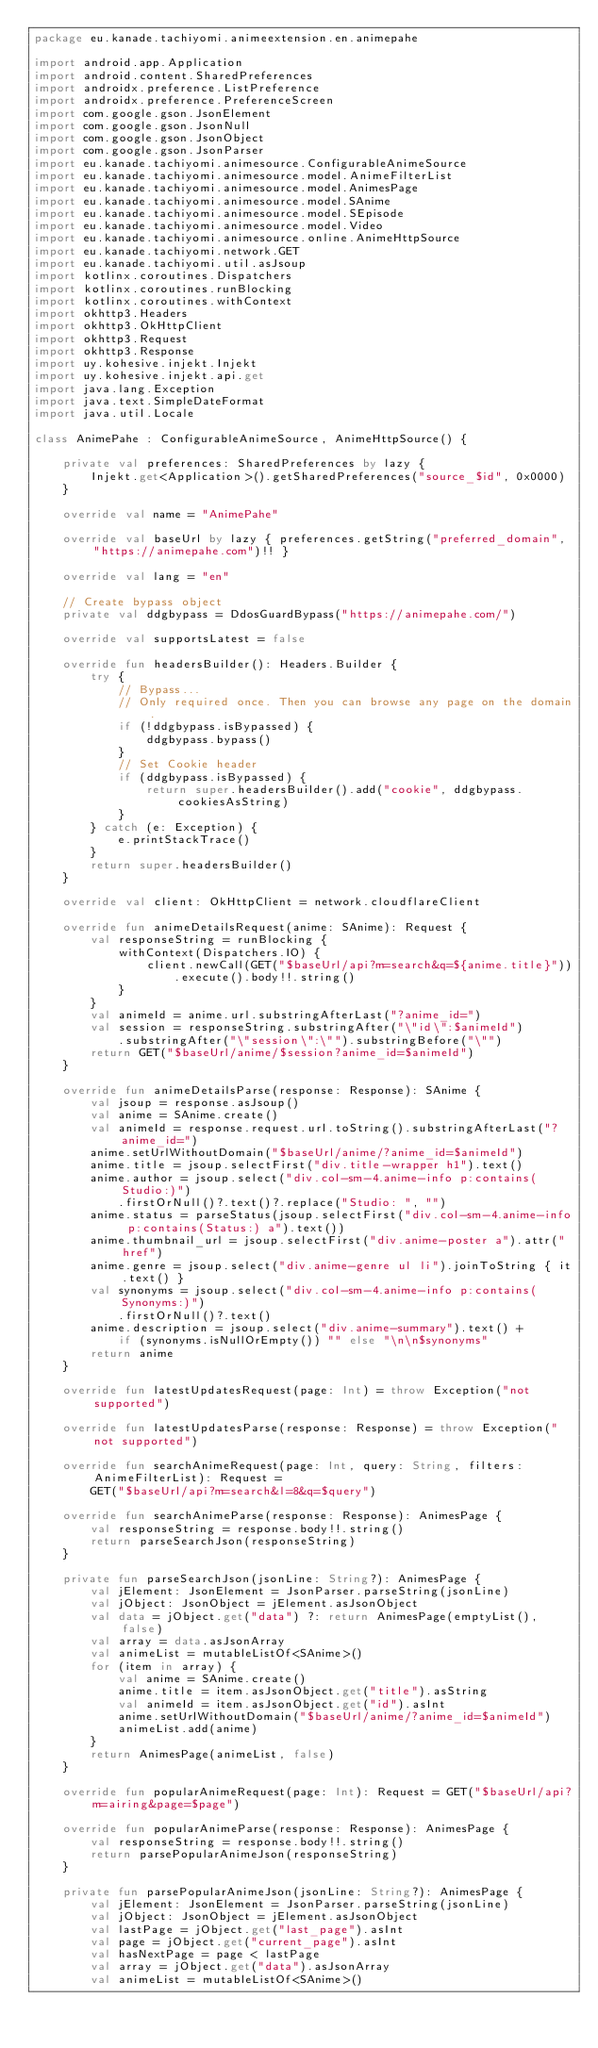Convert code to text. <code><loc_0><loc_0><loc_500><loc_500><_Kotlin_>package eu.kanade.tachiyomi.animeextension.en.animepahe

import android.app.Application
import android.content.SharedPreferences
import androidx.preference.ListPreference
import androidx.preference.PreferenceScreen
import com.google.gson.JsonElement
import com.google.gson.JsonNull
import com.google.gson.JsonObject
import com.google.gson.JsonParser
import eu.kanade.tachiyomi.animesource.ConfigurableAnimeSource
import eu.kanade.tachiyomi.animesource.model.AnimeFilterList
import eu.kanade.tachiyomi.animesource.model.AnimesPage
import eu.kanade.tachiyomi.animesource.model.SAnime
import eu.kanade.tachiyomi.animesource.model.SEpisode
import eu.kanade.tachiyomi.animesource.model.Video
import eu.kanade.tachiyomi.animesource.online.AnimeHttpSource
import eu.kanade.tachiyomi.network.GET
import eu.kanade.tachiyomi.util.asJsoup
import kotlinx.coroutines.Dispatchers
import kotlinx.coroutines.runBlocking
import kotlinx.coroutines.withContext
import okhttp3.Headers
import okhttp3.OkHttpClient
import okhttp3.Request
import okhttp3.Response
import uy.kohesive.injekt.Injekt
import uy.kohesive.injekt.api.get
import java.lang.Exception
import java.text.SimpleDateFormat
import java.util.Locale

class AnimePahe : ConfigurableAnimeSource, AnimeHttpSource() {

    private val preferences: SharedPreferences by lazy {
        Injekt.get<Application>().getSharedPreferences("source_$id", 0x0000)
    }

    override val name = "AnimePahe"

    override val baseUrl by lazy { preferences.getString("preferred_domain", "https://animepahe.com")!! }

    override val lang = "en"

    // Create bypass object
    private val ddgbypass = DdosGuardBypass("https://animepahe.com/")

    override val supportsLatest = false

    override fun headersBuilder(): Headers.Builder {
        try {
            // Bypass...
            // Only required once. Then you can browse any page on the domain.
            if (!ddgbypass.isBypassed) {
                ddgbypass.bypass()
            }
            // Set Cookie header
            if (ddgbypass.isBypassed) {
                return super.headersBuilder().add("cookie", ddgbypass.cookiesAsString)
            }
        } catch (e: Exception) {
            e.printStackTrace()
        }
        return super.headersBuilder()
    }

    override val client: OkHttpClient = network.cloudflareClient

    override fun animeDetailsRequest(anime: SAnime): Request {
        val responseString = runBlocking {
            withContext(Dispatchers.IO) {
                client.newCall(GET("$baseUrl/api?m=search&q=${anime.title}"))
                    .execute().body!!.string()
            }
        }
        val animeId = anime.url.substringAfterLast("?anime_id=")
        val session = responseString.substringAfter("\"id\":$animeId")
            .substringAfter("\"session\":\"").substringBefore("\"")
        return GET("$baseUrl/anime/$session?anime_id=$animeId")
    }

    override fun animeDetailsParse(response: Response): SAnime {
        val jsoup = response.asJsoup()
        val anime = SAnime.create()
        val animeId = response.request.url.toString().substringAfterLast("?anime_id=")
        anime.setUrlWithoutDomain("$baseUrl/anime/?anime_id=$animeId")
        anime.title = jsoup.selectFirst("div.title-wrapper h1").text()
        anime.author = jsoup.select("div.col-sm-4.anime-info p:contains(Studio:)")
            .firstOrNull()?.text()?.replace("Studio: ", "")
        anime.status = parseStatus(jsoup.selectFirst("div.col-sm-4.anime-info p:contains(Status:) a").text())
        anime.thumbnail_url = jsoup.selectFirst("div.anime-poster a").attr("href")
        anime.genre = jsoup.select("div.anime-genre ul li").joinToString { it.text() }
        val synonyms = jsoup.select("div.col-sm-4.anime-info p:contains(Synonyms:)")
            .firstOrNull()?.text()
        anime.description = jsoup.select("div.anime-summary").text() +
            if (synonyms.isNullOrEmpty()) "" else "\n\n$synonyms"
        return anime
    }

    override fun latestUpdatesRequest(page: Int) = throw Exception("not supported")

    override fun latestUpdatesParse(response: Response) = throw Exception("not supported")

    override fun searchAnimeRequest(page: Int, query: String, filters: AnimeFilterList): Request =
        GET("$baseUrl/api?m=search&l=8&q=$query")

    override fun searchAnimeParse(response: Response): AnimesPage {
        val responseString = response.body!!.string()
        return parseSearchJson(responseString)
    }

    private fun parseSearchJson(jsonLine: String?): AnimesPage {
        val jElement: JsonElement = JsonParser.parseString(jsonLine)
        val jObject: JsonObject = jElement.asJsonObject
        val data = jObject.get("data") ?: return AnimesPage(emptyList(), false)
        val array = data.asJsonArray
        val animeList = mutableListOf<SAnime>()
        for (item in array) {
            val anime = SAnime.create()
            anime.title = item.asJsonObject.get("title").asString
            val animeId = item.asJsonObject.get("id").asInt
            anime.setUrlWithoutDomain("$baseUrl/anime/?anime_id=$animeId")
            animeList.add(anime)
        }
        return AnimesPage(animeList, false)
    }

    override fun popularAnimeRequest(page: Int): Request = GET("$baseUrl/api?m=airing&page=$page")

    override fun popularAnimeParse(response: Response): AnimesPage {
        val responseString = response.body!!.string()
        return parsePopularAnimeJson(responseString)
    }

    private fun parsePopularAnimeJson(jsonLine: String?): AnimesPage {
        val jElement: JsonElement = JsonParser.parseString(jsonLine)
        val jObject: JsonObject = jElement.asJsonObject
        val lastPage = jObject.get("last_page").asInt
        val page = jObject.get("current_page").asInt
        val hasNextPage = page < lastPage
        val array = jObject.get("data").asJsonArray
        val animeList = mutableListOf<SAnime>()</code> 